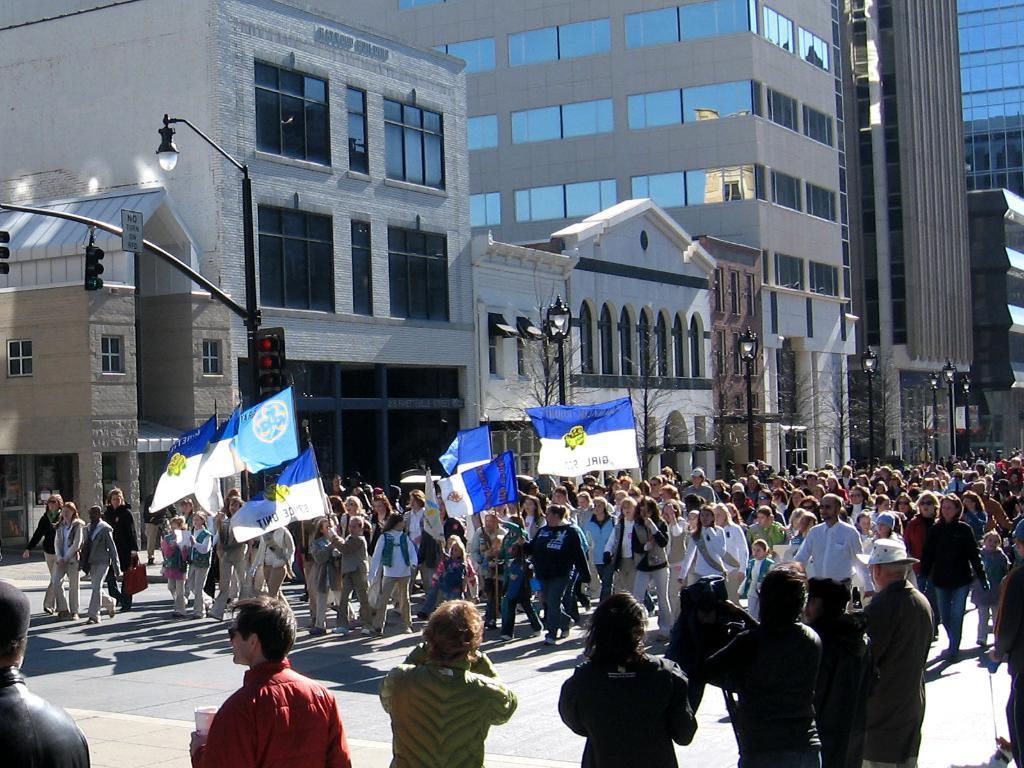Could you give a brief overview of what you see in this image? In this image there are group of people walking on the road by holding flags , and in the background there are lights, poles, buildings, trees. 